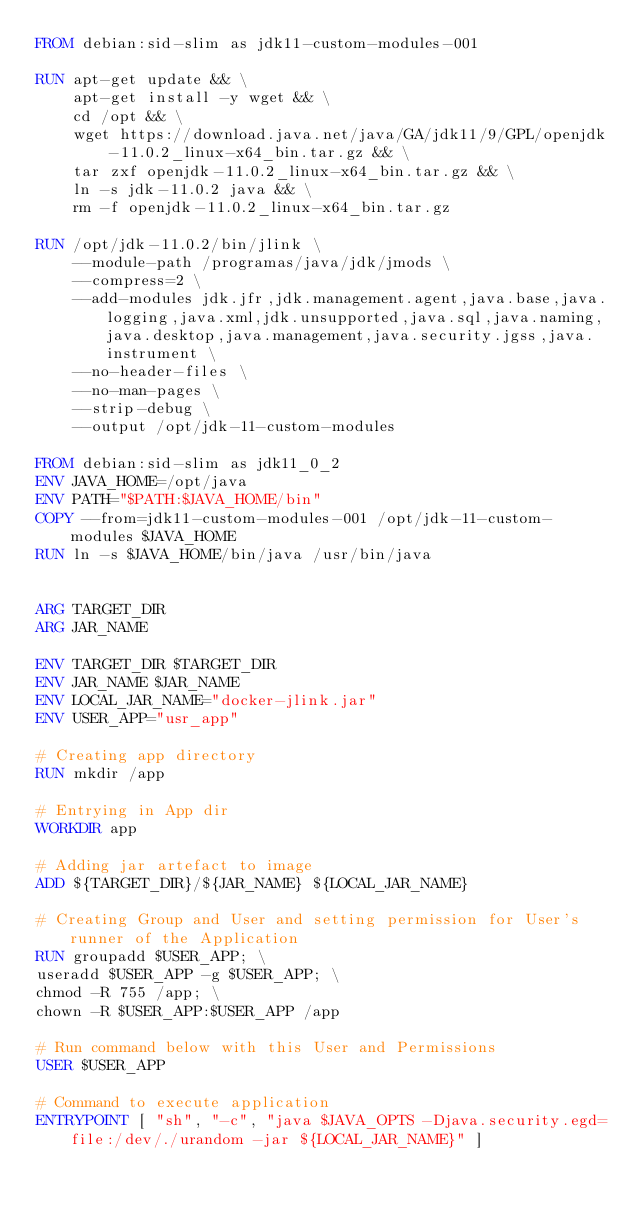<code> <loc_0><loc_0><loc_500><loc_500><_Dockerfile_>FROM debian:sid-slim as jdk11-custom-modules-001

RUN apt-get update && \
    apt-get install -y wget && \
    cd /opt && \
    wget https://download.java.net/java/GA/jdk11/9/GPL/openjdk-11.0.2_linux-x64_bin.tar.gz && \
    tar zxf openjdk-11.0.2_linux-x64_bin.tar.gz && \
    ln -s jdk-11.0.2 java && \
    rm -f openjdk-11.0.2_linux-x64_bin.tar.gz

RUN /opt/jdk-11.0.2/bin/jlink \
    --module-path /programas/java/jdk/jmods \
    --compress=2 \
    --add-modules jdk.jfr,jdk.management.agent,java.base,java.logging,java.xml,jdk.unsupported,java.sql,java.naming,java.desktop,java.management,java.security.jgss,java.instrument \
    --no-header-files \
    --no-man-pages \
    --strip-debug \
    --output /opt/jdk-11-custom-modules

FROM debian:sid-slim as jdk11_0_2
ENV JAVA_HOME=/opt/java
ENV PATH="$PATH:$JAVA_HOME/bin"
COPY --from=jdk11-custom-modules-001 /opt/jdk-11-custom-modules $JAVA_HOME
RUN ln -s $JAVA_HOME/bin/java /usr/bin/java


ARG TARGET_DIR
ARG JAR_NAME

ENV TARGET_DIR $TARGET_DIR
ENV JAR_NAME $JAR_NAME
ENV LOCAL_JAR_NAME="docker-jlink.jar"
ENV USER_APP="usr_app"

# Creating app directory
RUN mkdir /app

# Entrying in App dir
WORKDIR app

# Adding jar artefact to image
ADD ${TARGET_DIR}/${JAR_NAME} ${LOCAL_JAR_NAME}

# Creating Group and User and setting permission for User's runner of the Application
RUN groupadd $USER_APP; \
useradd $USER_APP -g $USER_APP; \
chmod -R 755 /app; \
chown -R $USER_APP:$USER_APP /app

# Run command below with this User and Permissions
USER $USER_APP

# Command to execute application
ENTRYPOINT [ "sh", "-c", "java $JAVA_OPTS -Djava.security.egd=file:/dev/./urandom -jar ${LOCAL_JAR_NAME}" ]</code> 